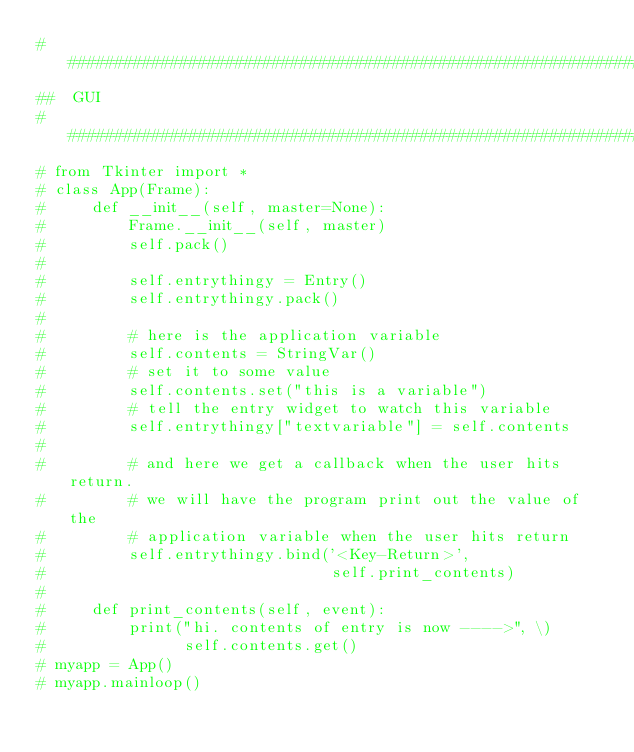<code> <loc_0><loc_0><loc_500><loc_500><_Python_>################################################################################
##  GUI
################################################################################
# from Tkinter import *
# class App(Frame):
#     def __init__(self, master=None):
#         Frame.__init__(self, master)
#         self.pack()
#         
#         self.entrythingy = Entry()
#         self.entrythingy.pack()
#         
#         # here is the application variable
#         self.contents = StringVar()
#         # set it to some value
#         self.contents.set("this is a variable")
#         # tell the entry widget to watch this variable
#         self.entrythingy["textvariable"] = self.contents
#         
#         # and here we get a callback when the user hits return.
#         # we will have the program print out the value of the
#         # application variable when the user hits return
#         self.entrythingy.bind('<Key-Return>',
#                               self.print_contents)
# 
#     def print_contents(self, event):
#         print("hi. contents of entry is now ---->", \)
#               self.contents.get()
# myapp = App()
# myapp.mainloop()

</code> 